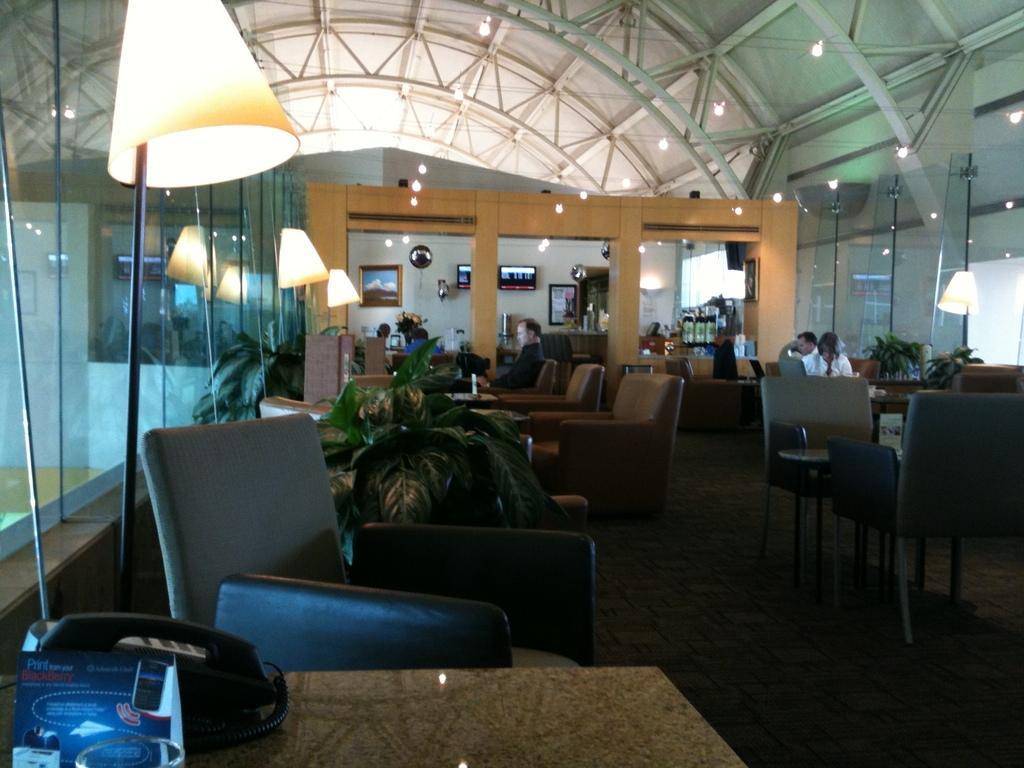Can you describe this image briefly? There are few persons sitting on the chairs. Here we can see chairs, tables, phone, lamps, and plants. This is floor. In the background we can see frames and screens on the wall. 